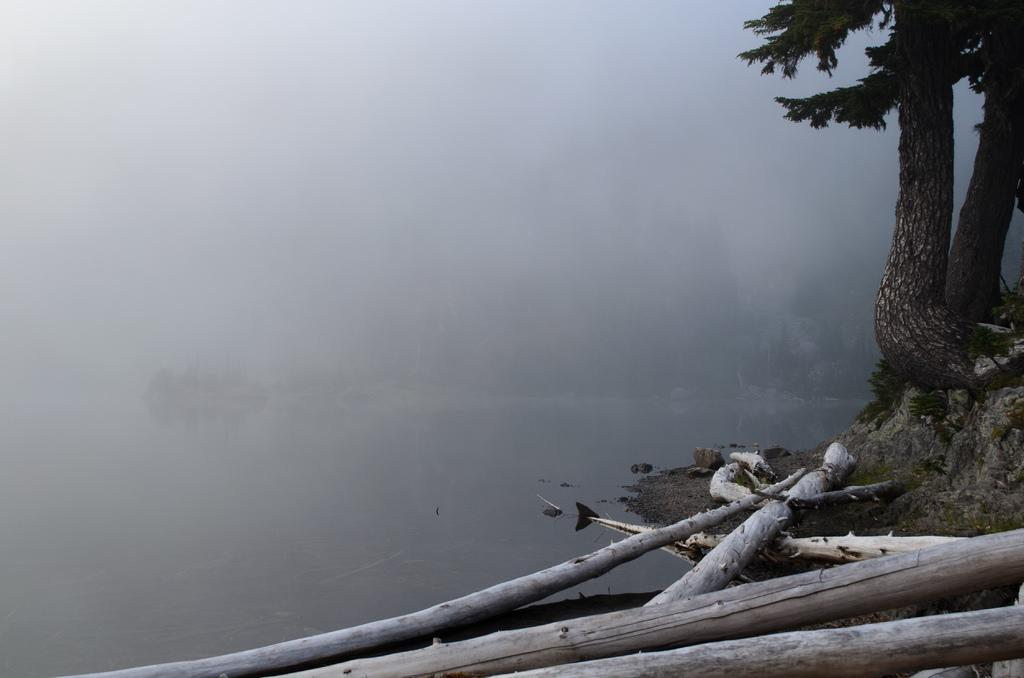What objects are located on the right side of the image? There are wooden sticks and trees on the right side of the image. What type of vegetation is present in the image? There are trees in the image. What can be seen in the background of the image? There are trees and water visible in the background of the image. What part of the natural environment is visible in the background of the image? The sky is visible in the background of the image. What type of power is being generated by the trees in the image? There is no indication in the image that the trees are generating any power. How does the police presence affect the scene in the image? There is no police presence depicted in the image. 